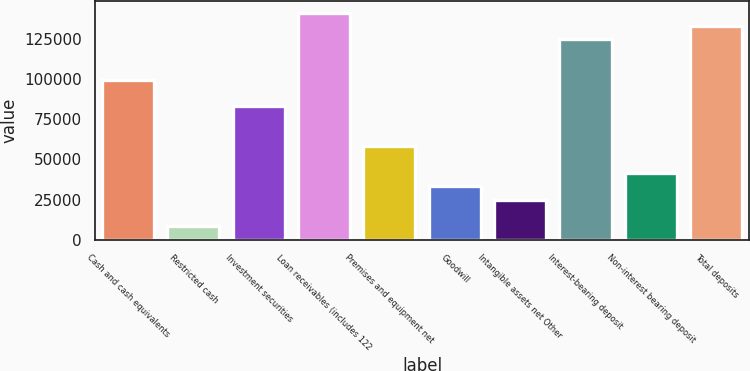Convert chart. <chart><loc_0><loc_0><loc_500><loc_500><bar_chart><fcel>Cash and cash equivalents<fcel>Restricted cash<fcel>Investment securities<fcel>Loan receivables (includes 122<fcel>Premises and equipment net<fcel>Goodwill<fcel>Intangible assets net Other<fcel>Interest-bearing deposit<fcel>Non-interest bearing deposit<fcel>Total deposits<nl><fcel>99750.2<fcel>8317.1<fcel>83126<fcel>141311<fcel>58189.7<fcel>33253.4<fcel>24941.3<fcel>124686<fcel>41565.5<fcel>132999<nl></chart> 